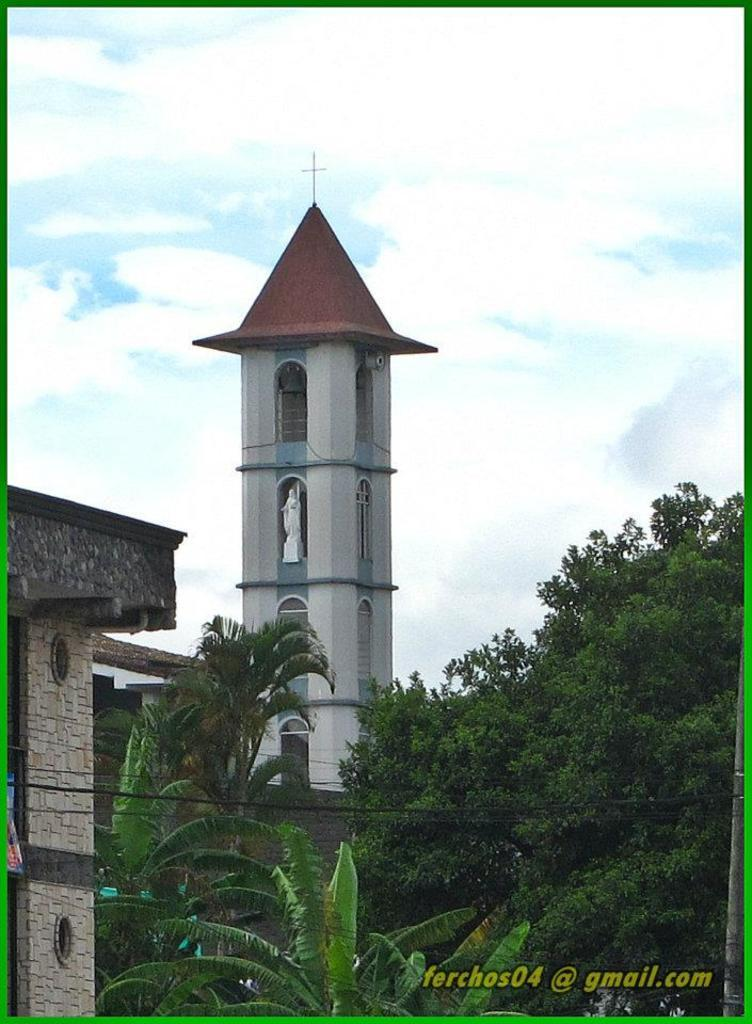What type of structures can be seen in the image? There are buildings in the image. What other natural elements are present in the image? There are trees in the image. How would you describe the sky in the image? The sky is blue and cloudy in the image. Is there any text or writing in the image? Yes, there is text in the bottom right corner of the image. How many kittens are playing with a yam under a stocking in the image? There are no kittens, yams, or stockings present in the image. 